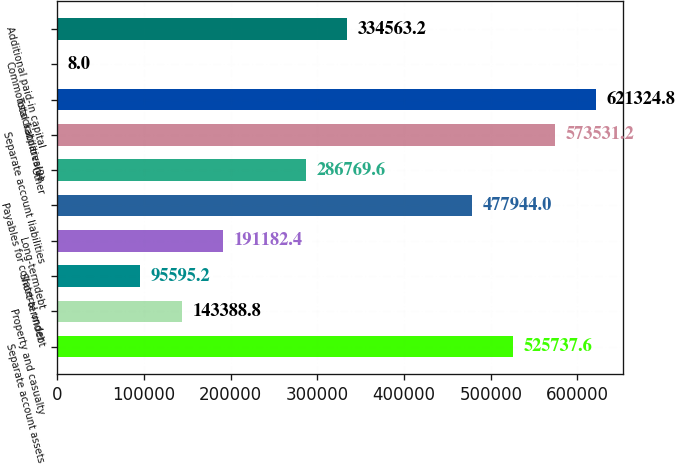Convert chart. <chart><loc_0><loc_0><loc_500><loc_500><bar_chart><fcel>Separate account assets<fcel>Property and casualty<fcel>Short-termdebt<fcel>Long-termdebt<fcel>Payables for collateral under<fcel>Other<fcel>Separate account liabilities<fcel>Total liabilities(2)<fcel>Commonstockatparvalue<fcel>Additional paid-in capital<nl><fcel>525738<fcel>143389<fcel>95595.2<fcel>191182<fcel>477944<fcel>286770<fcel>573531<fcel>621325<fcel>8<fcel>334563<nl></chart> 